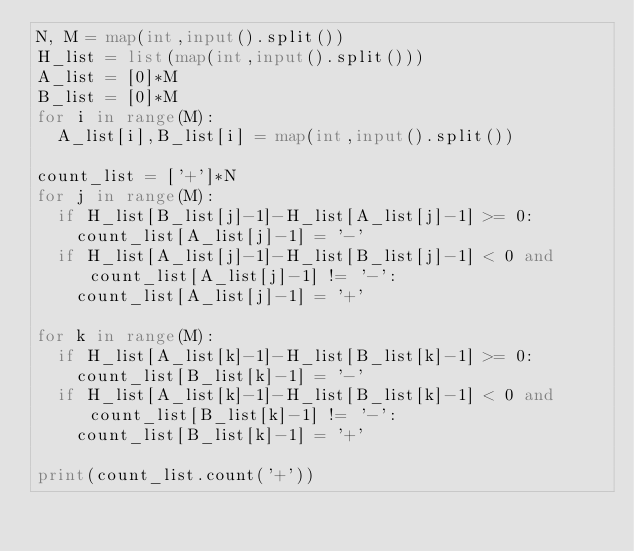<code> <loc_0><loc_0><loc_500><loc_500><_Python_>N, M = map(int,input().split())
H_list = list(map(int,input().split()))
A_list = [0]*M
B_list = [0]*M
for i in range(M):
  A_list[i],B_list[i] = map(int,input().split())

count_list = ['+']*N
for j in range(M):
  if H_list[B_list[j]-1]-H_list[A_list[j]-1] >= 0:
    count_list[A_list[j]-1] = '-'
  if H_list[A_list[j]-1]-H_list[B_list[j]-1] < 0 and count_list[A_list[j]-1] != '-':
    count_list[A_list[j]-1] = '+'

for k in range(M):
  if H_list[A_list[k]-1]-H_list[B_list[k]-1] >= 0:
    count_list[B_list[k]-1] = '-'
  if H_list[A_list[k]-1]-H_list[B_list[k]-1] < 0 and count_list[B_list[k]-1] != '-':
    count_list[B_list[k]-1] = '+'
 
print(count_list.count('+'))</code> 